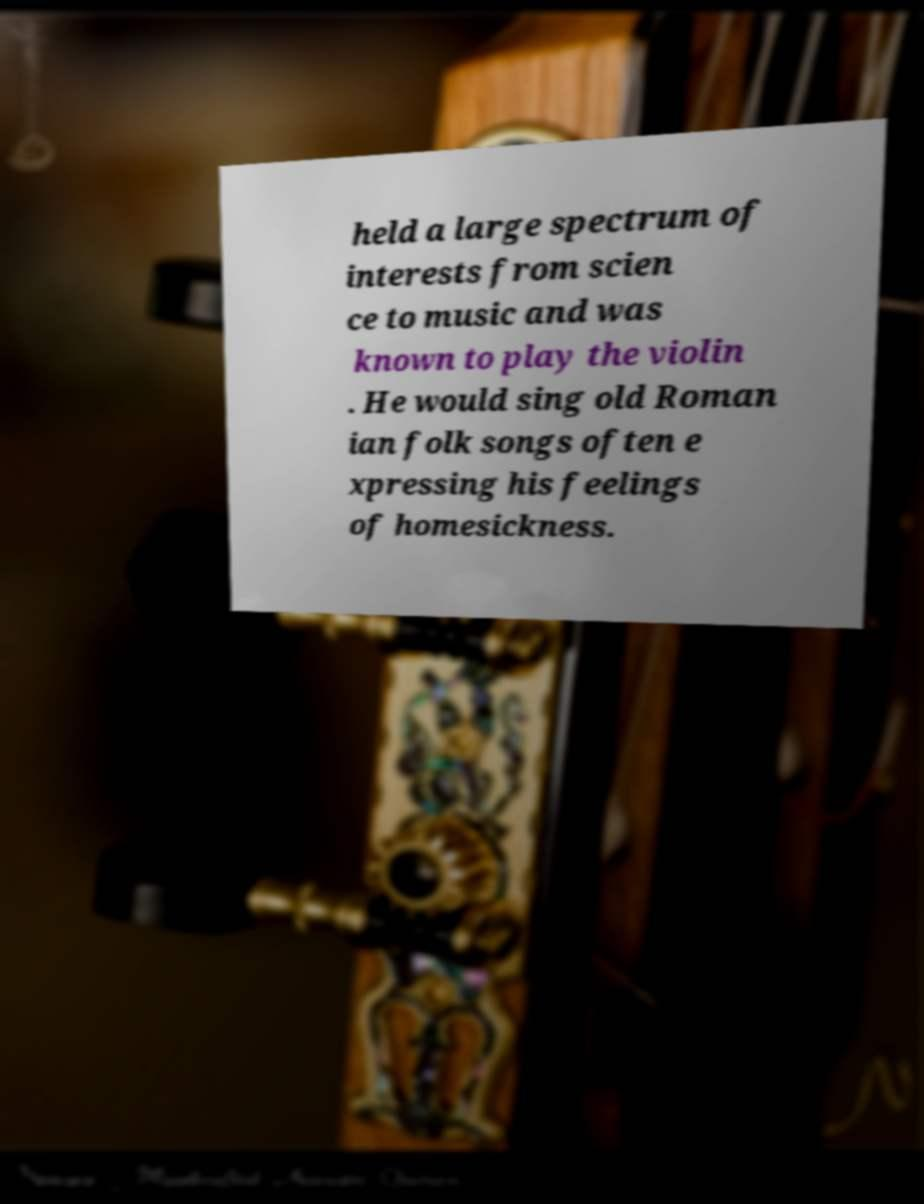Please read and relay the text visible in this image. What does it say? held a large spectrum of interests from scien ce to music and was known to play the violin . He would sing old Roman ian folk songs often e xpressing his feelings of homesickness. 